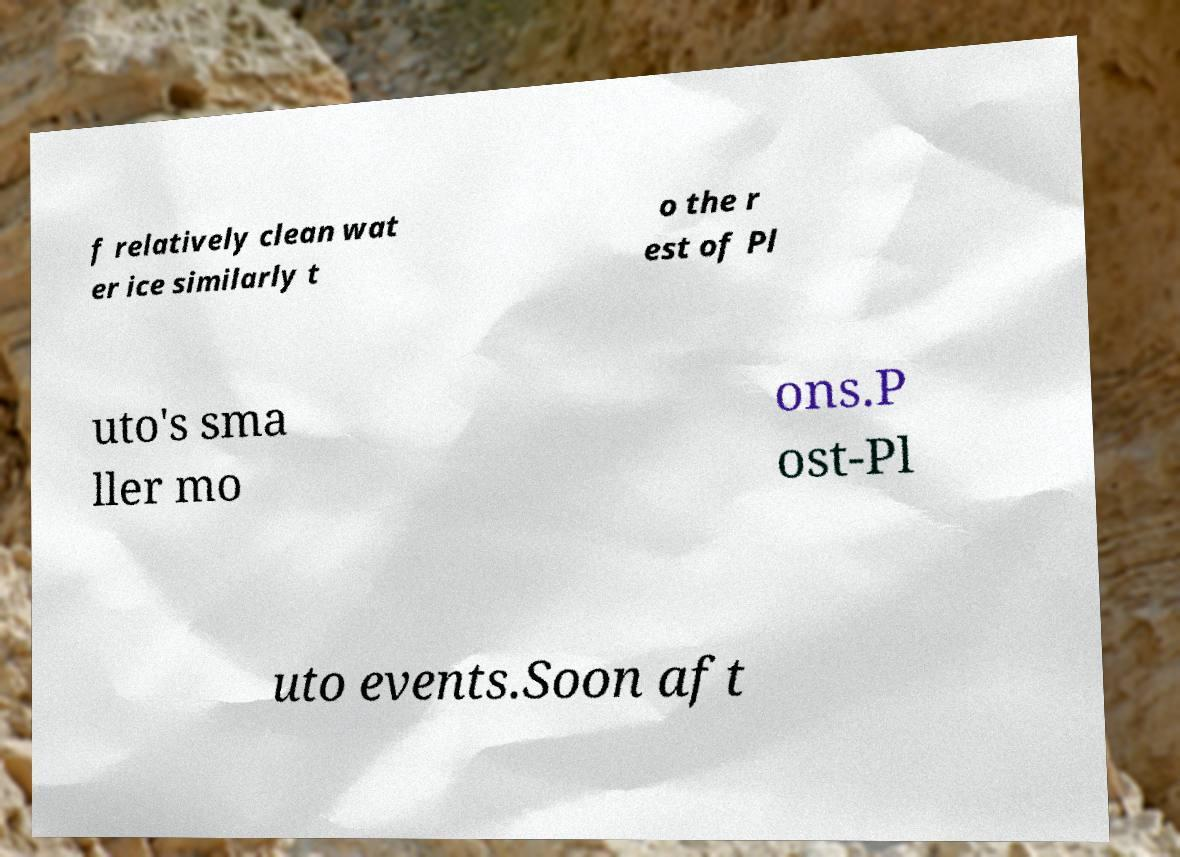I need the written content from this picture converted into text. Can you do that? f relatively clean wat er ice similarly t o the r est of Pl uto's sma ller mo ons.P ost-Pl uto events.Soon aft 